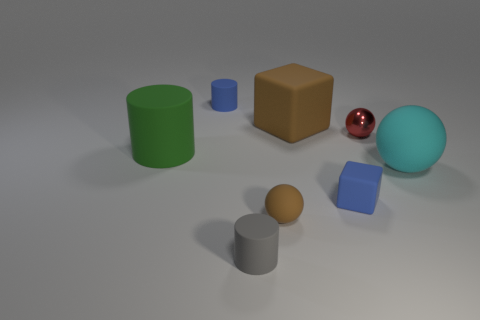There is a tiny matte thing that is the same color as the big matte cube; what shape is it?
Make the answer very short. Sphere. There is a cyan rubber object that is the same shape as the red object; what size is it?
Make the answer very short. Large. There is a object that is both left of the brown matte block and behind the tiny metallic ball; how big is it?
Offer a very short reply. Small. There is a tiny rubber cube; is it the same color as the big object left of the gray cylinder?
Give a very brief answer. No. How many yellow things are small things or small shiny balls?
Provide a short and direct response. 0. What shape is the small gray object?
Your answer should be compact. Cylinder. What number of other things are the same shape as the small metallic thing?
Your response must be concise. 2. What color is the small rubber object that is behind the large rubber ball?
Keep it short and to the point. Blue. Do the tiny gray cylinder and the brown sphere have the same material?
Your answer should be very brief. Yes. How many objects are either big cyan matte objects or brown rubber things in front of the metallic object?
Give a very brief answer. 2. 